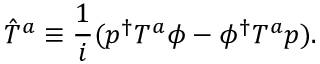Convert formula to latex. <formula><loc_0><loc_0><loc_500><loc_500>\hat { T } ^ { a } \equiv \frac { 1 } { i } ( p ^ { \dagger } T ^ { a } \phi - \phi ^ { \dagger } T ^ { a } p ) .</formula> 